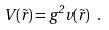Convert formula to latex. <formula><loc_0><loc_0><loc_500><loc_500>V ( \vec { r } ) = g ^ { 2 } v ( \vec { r } ) \ .</formula> 